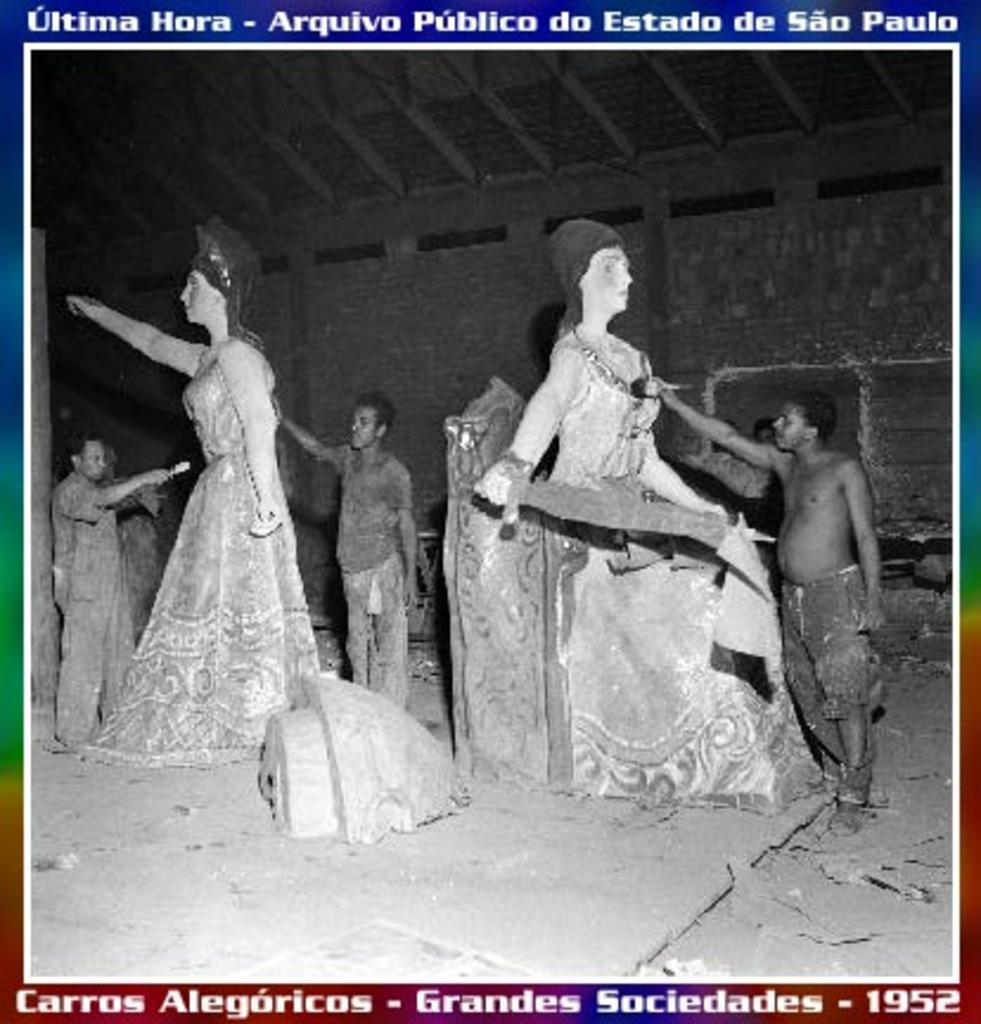<image>
Present a compact description of the photo's key features. A poster displays the date 1952 in its bottom right corner. 